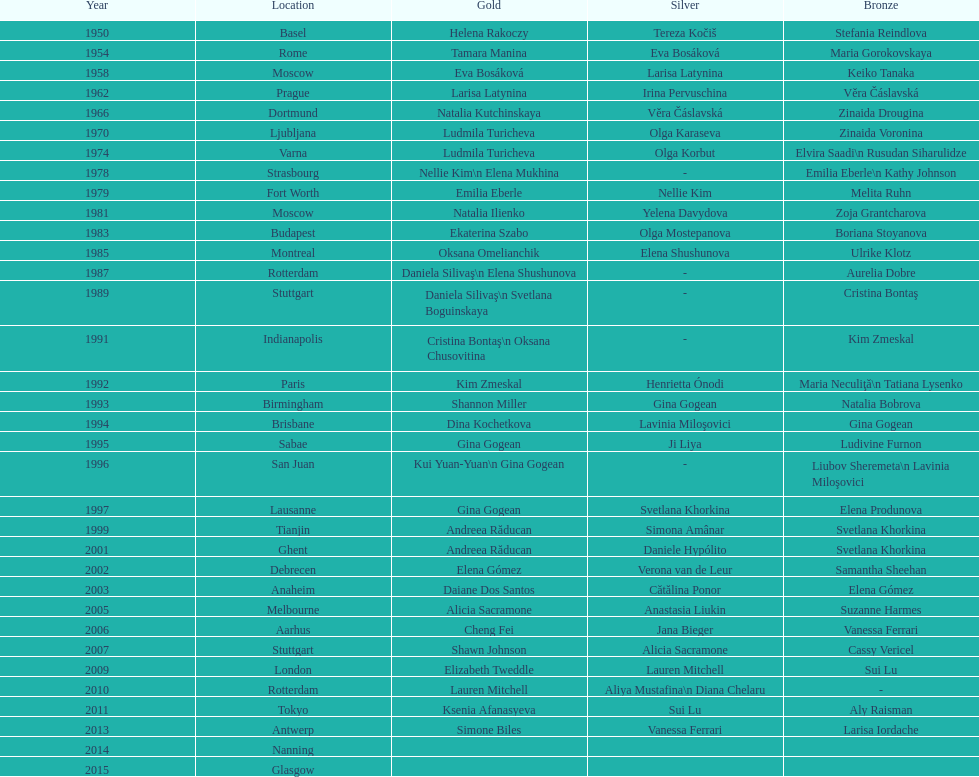How many times was the location in the united states? 3. 